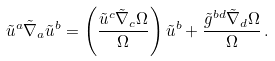<formula> <loc_0><loc_0><loc_500><loc_500>\tilde { u } ^ { a } \tilde { \nabla } _ { a } \tilde { u } ^ { b } = \left ( \frac { \tilde { u } ^ { c } \tilde { \nabla } _ { c } \Omega } { \Omega } \right ) \tilde { u } ^ { b } + \frac { \tilde { g } ^ { b d } \tilde { \nabla } _ { d } \Omega } { \Omega } \, .</formula> 